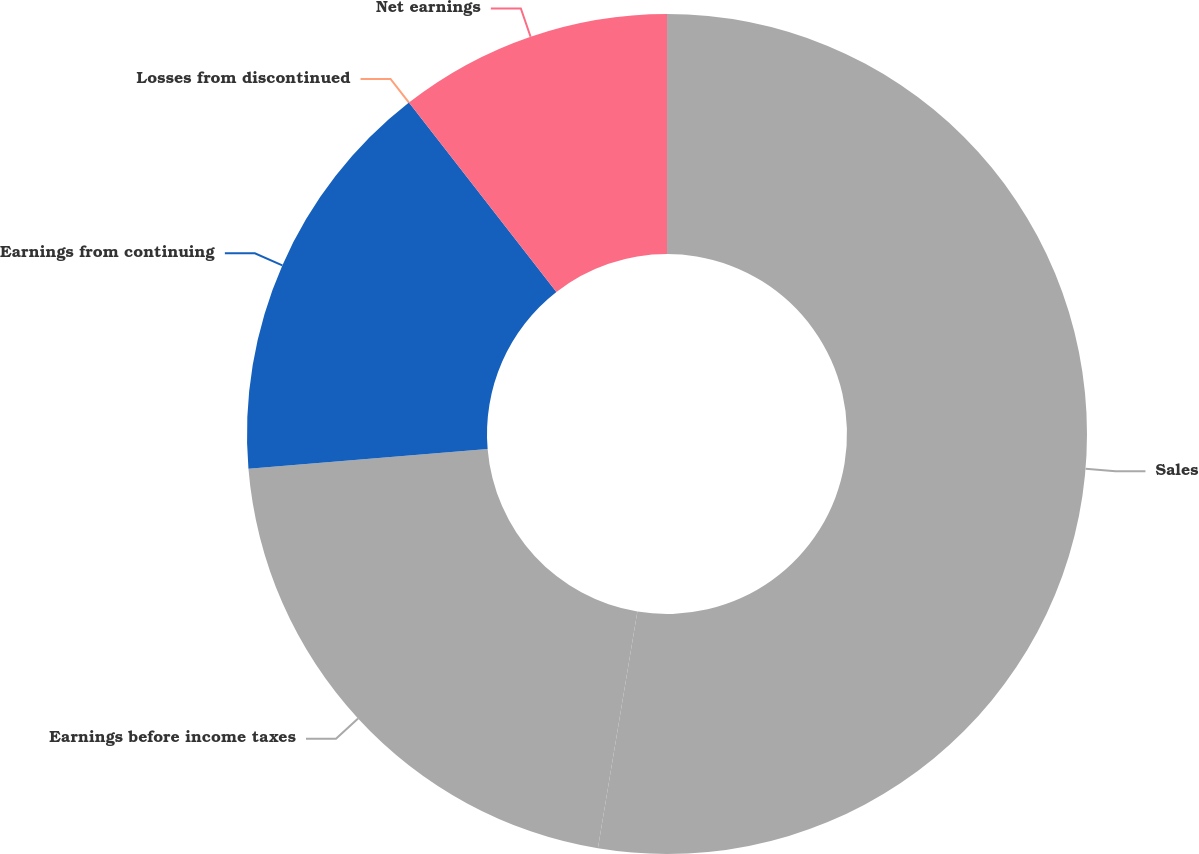Convert chart to OTSL. <chart><loc_0><loc_0><loc_500><loc_500><pie_chart><fcel>Sales<fcel>Earnings before income taxes<fcel>Earnings from continuing<fcel>Losses from discontinued<fcel>Net earnings<nl><fcel>52.63%<fcel>21.05%<fcel>15.79%<fcel>0.0%<fcel>10.53%<nl></chart> 